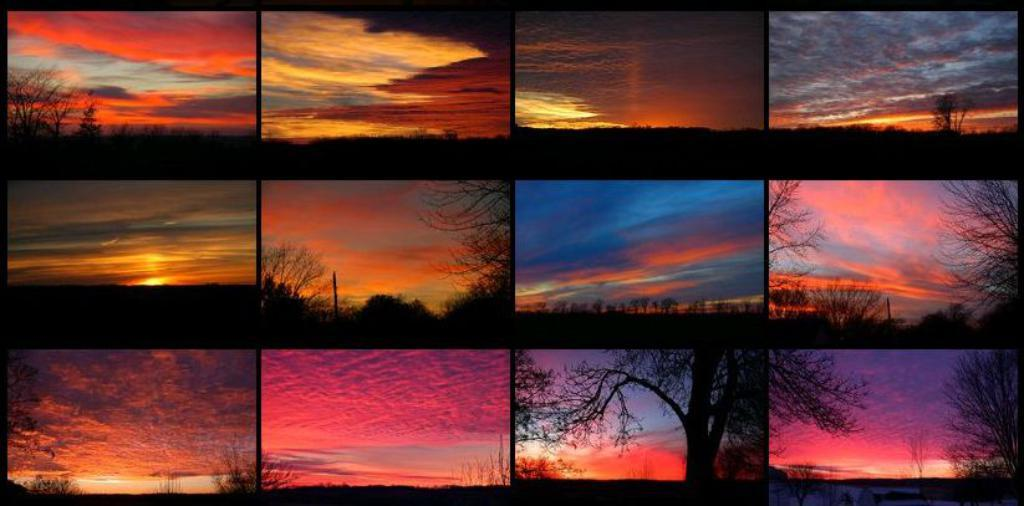What type of artwork is shown in the image? The image is a collage of pictures. What natural elements can be seen in the collage? There are trees and clouds depicted in the collage. What type of toy is being played with under the tree in the image? There is no toy or person playing with a toy depicted in the image; it is a collage of pictures featuring trees and clouds. 